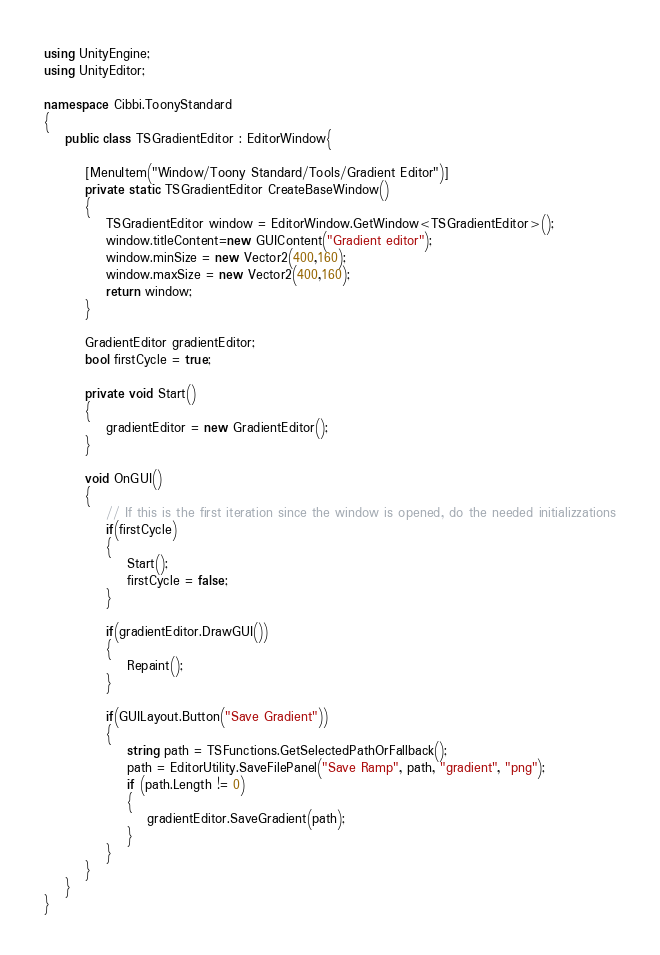Convert code to text. <code><loc_0><loc_0><loc_500><loc_500><_C#_>using UnityEngine;
using UnityEditor;

namespace Cibbi.ToonyStandard
{
    public class TSGradientEditor : EditorWindow{

        [MenuItem("Window/Toony Standard/Tools/Gradient Editor")]
        private static TSGradientEditor CreateBaseWindow()
        {
            TSGradientEditor window = EditorWindow.GetWindow<TSGradientEditor>();
            window.titleContent=new GUIContent("Gradient editor");
            window.minSize = new Vector2(400,160);
            window.maxSize = new Vector2(400,160);
            return window;
        }

        GradientEditor gradientEditor;
        bool firstCycle = true;
    
        private void Start()
        {
            gradientEditor = new GradientEditor();
        }

        void OnGUI()
        {
            // If this is the first iteration since the window is opened, do the needed initializzations
			if(firstCycle)
			{
				Start();
                firstCycle = false;
			}

            if(gradientEditor.DrawGUI())
            {
                Repaint();
            }

            if(GUILayout.Button("Save Gradient"))
            {
                string path = TSFunctions.GetSelectedPathOrFallback();
                path = EditorUtility.SaveFilePanel("Save Ramp", path, "gradient", "png");
                if (path.Length != 0)
                {
                    gradientEditor.SaveGradient(path);
                }
            }
        }
    }
}</code> 